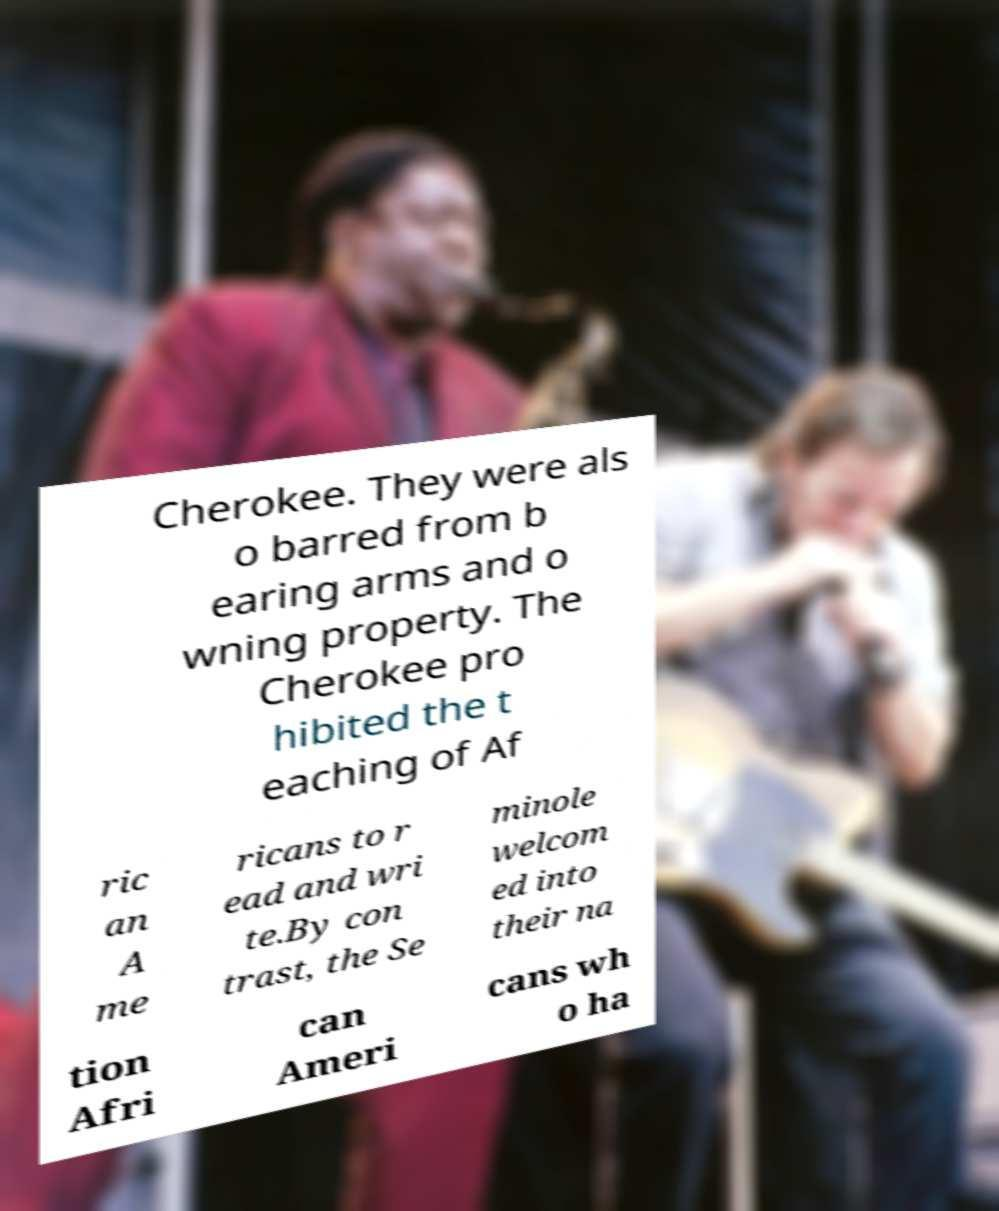Please identify and transcribe the text found in this image. Cherokee. They were als o barred from b earing arms and o wning property. The Cherokee pro hibited the t eaching of Af ric an A me ricans to r ead and wri te.By con trast, the Se minole welcom ed into their na tion Afri can Ameri cans wh o ha 